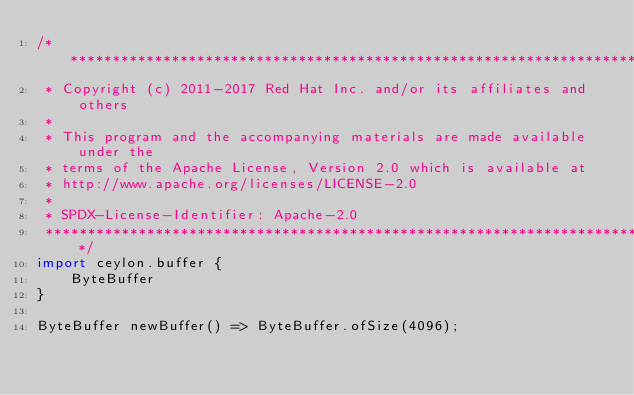<code> <loc_0><loc_0><loc_500><loc_500><_Ceylon_>/********************************************************************************
 * Copyright (c) 2011-2017 Red Hat Inc. and/or its affiliates and others
 *
 * This program and the accompanying materials are made available under the 
 * terms of the Apache License, Version 2.0 which is available at
 * http://www.apache.org/licenses/LICENSE-2.0
 *
 * SPDX-License-Identifier: Apache-2.0 
 ********************************************************************************/
import ceylon.buffer {
    ByteBuffer
}

ByteBuffer newBuffer() => ByteBuffer.ofSize(4096);
</code> 